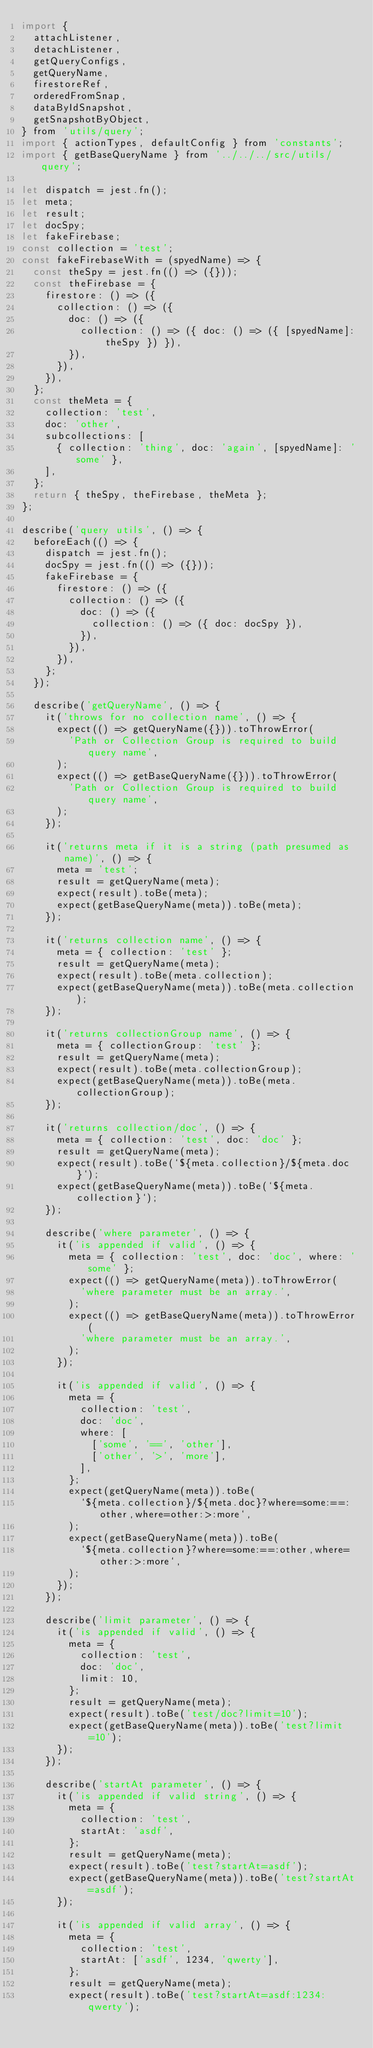Convert code to text. <code><loc_0><loc_0><loc_500><loc_500><_JavaScript_>import {
  attachListener,
  detachListener,
  getQueryConfigs,
  getQueryName,
  firestoreRef,
  orderedFromSnap,
  dataByIdSnapshot,
  getSnapshotByObject,
} from 'utils/query';
import { actionTypes, defaultConfig } from 'constants';
import { getBaseQueryName } from '../../../src/utils/query';

let dispatch = jest.fn();
let meta;
let result;
let docSpy;
let fakeFirebase;
const collection = 'test';
const fakeFirebaseWith = (spyedName) => {
  const theSpy = jest.fn(() => ({}));
  const theFirebase = {
    firestore: () => ({
      collection: () => ({
        doc: () => ({
          collection: () => ({ doc: () => ({ [spyedName]: theSpy }) }),
        }),
      }),
    }),
  };
  const theMeta = {
    collection: 'test',
    doc: 'other',
    subcollections: [
      { collection: 'thing', doc: 'again', [spyedName]: 'some' },
    ],
  };
  return { theSpy, theFirebase, theMeta };
};

describe('query utils', () => {
  beforeEach(() => {
    dispatch = jest.fn();
    docSpy = jest.fn(() => ({}));
    fakeFirebase = {
      firestore: () => ({
        collection: () => ({
          doc: () => ({
            collection: () => ({ doc: docSpy }),
          }),
        }),
      }),
    };
  });

  describe('getQueryName', () => {
    it('throws for no collection name', () => {
      expect(() => getQueryName({})).toThrowError(
        'Path or Collection Group is required to build query name',
      );
      expect(() => getBaseQueryName({})).toThrowError(
        'Path or Collection Group is required to build query name',
      );
    });

    it('returns meta if it is a string (path presumed as name)', () => {
      meta = 'test';
      result = getQueryName(meta);
      expect(result).toBe(meta);
      expect(getBaseQueryName(meta)).toBe(meta);
    });

    it('returns collection name', () => {
      meta = { collection: 'test' };
      result = getQueryName(meta);
      expect(result).toBe(meta.collection);
      expect(getBaseQueryName(meta)).toBe(meta.collection);
    });

    it('returns collectionGroup name', () => {
      meta = { collectionGroup: 'test' };
      result = getQueryName(meta);
      expect(result).toBe(meta.collectionGroup);
      expect(getBaseQueryName(meta)).toBe(meta.collectionGroup);
    });

    it('returns collection/doc', () => {
      meta = { collection: 'test', doc: 'doc' };
      result = getQueryName(meta);
      expect(result).toBe(`${meta.collection}/${meta.doc}`);
      expect(getBaseQueryName(meta)).toBe(`${meta.collection}`);
    });

    describe('where parameter', () => {
      it('is appended if valid', () => {
        meta = { collection: 'test', doc: 'doc', where: 'some' };
        expect(() => getQueryName(meta)).toThrowError(
          'where parameter must be an array.',
        );
        expect(() => getBaseQueryName(meta)).toThrowError(
          'where parameter must be an array.',
        );
      });

      it('is appended if valid', () => {
        meta = {
          collection: 'test',
          doc: 'doc',
          where: [
            ['some', '==', 'other'],
            ['other', '>', 'more'],
          ],
        };
        expect(getQueryName(meta)).toBe(
          `${meta.collection}/${meta.doc}?where=some:==:other,where=other:>:more`,
        );
        expect(getBaseQueryName(meta)).toBe(
          `${meta.collection}?where=some:==:other,where=other:>:more`,
        );
      });
    });

    describe('limit parameter', () => {
      it('is appended if valid', () => {
        meta = {
          collection: 'test',
          doc: 'doc',
          limit: 10,
        };
        result = getQueryName(meta);
        expect(result).toBe('test/doc?limit=10');
        expect(getBaseQueryName(meta)).toBe('test?limit=10');
      });
    });

    describe('startAt parameter', () => {
      it('is appended if valid string', () => {
        meta = {
          collection: 'test',
          startAt: 'asdf',
        };
        result = getQueryName(meta);
        expect(result).toBe('test?startAt=asdf');
        expect(getBaseQueryName(meta)).toBe('test?startAt=asdf');
      });

      it('is appended if valid array', () => {
        meta = {
          collection: 'test',
          startAt: ['asdf', 1234, 'qwerty'],
        };
        result = getQueryName(meta);
        expect(result).toBe('test?startAt=asdf:1234:qwerty');</code> 